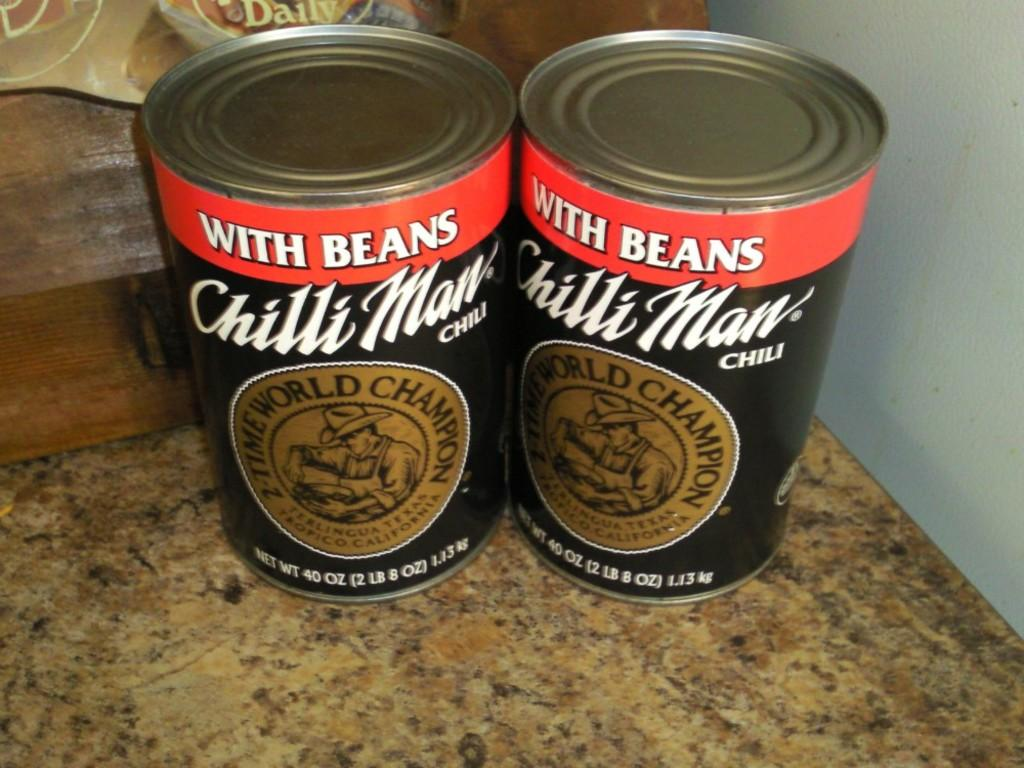<image>
Present a compact description of the photo's key features. Two cans that say "with beans" next to one another on a table. 